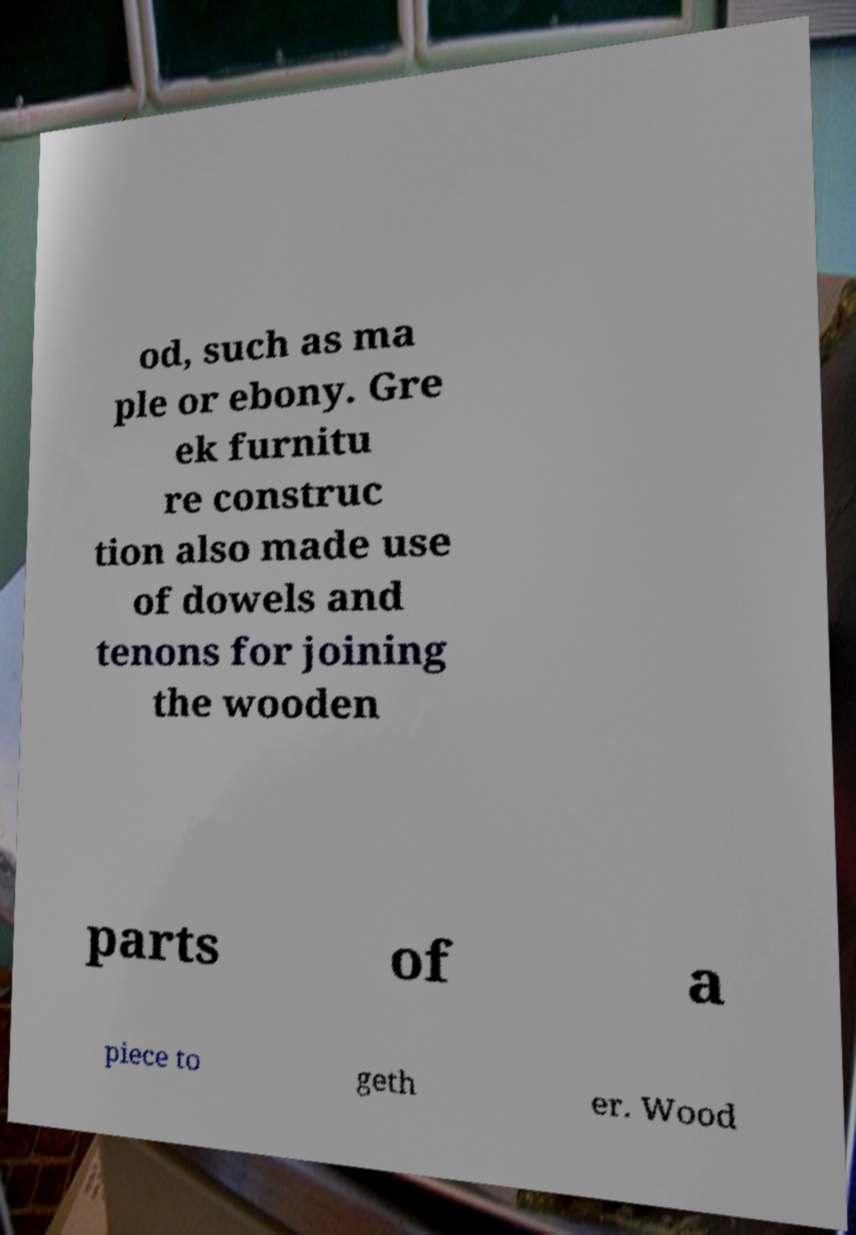Can you read and provide the text displayed in the image?This photo seems to have some interesting text. Can you extract and type it out for me? od, such as ma ple or ebony. Gre ek furnitu re construc tion also made use of dowels and tenons for joining the wooden parts of a piece to geth er. Wood 